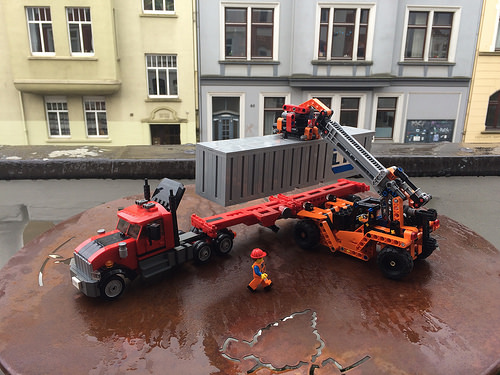<image>
Can you confirm if the lego container is above the lego truck? Yes. The lego container is positioned above the lego truck in the vertical space, higher up in the scene. 